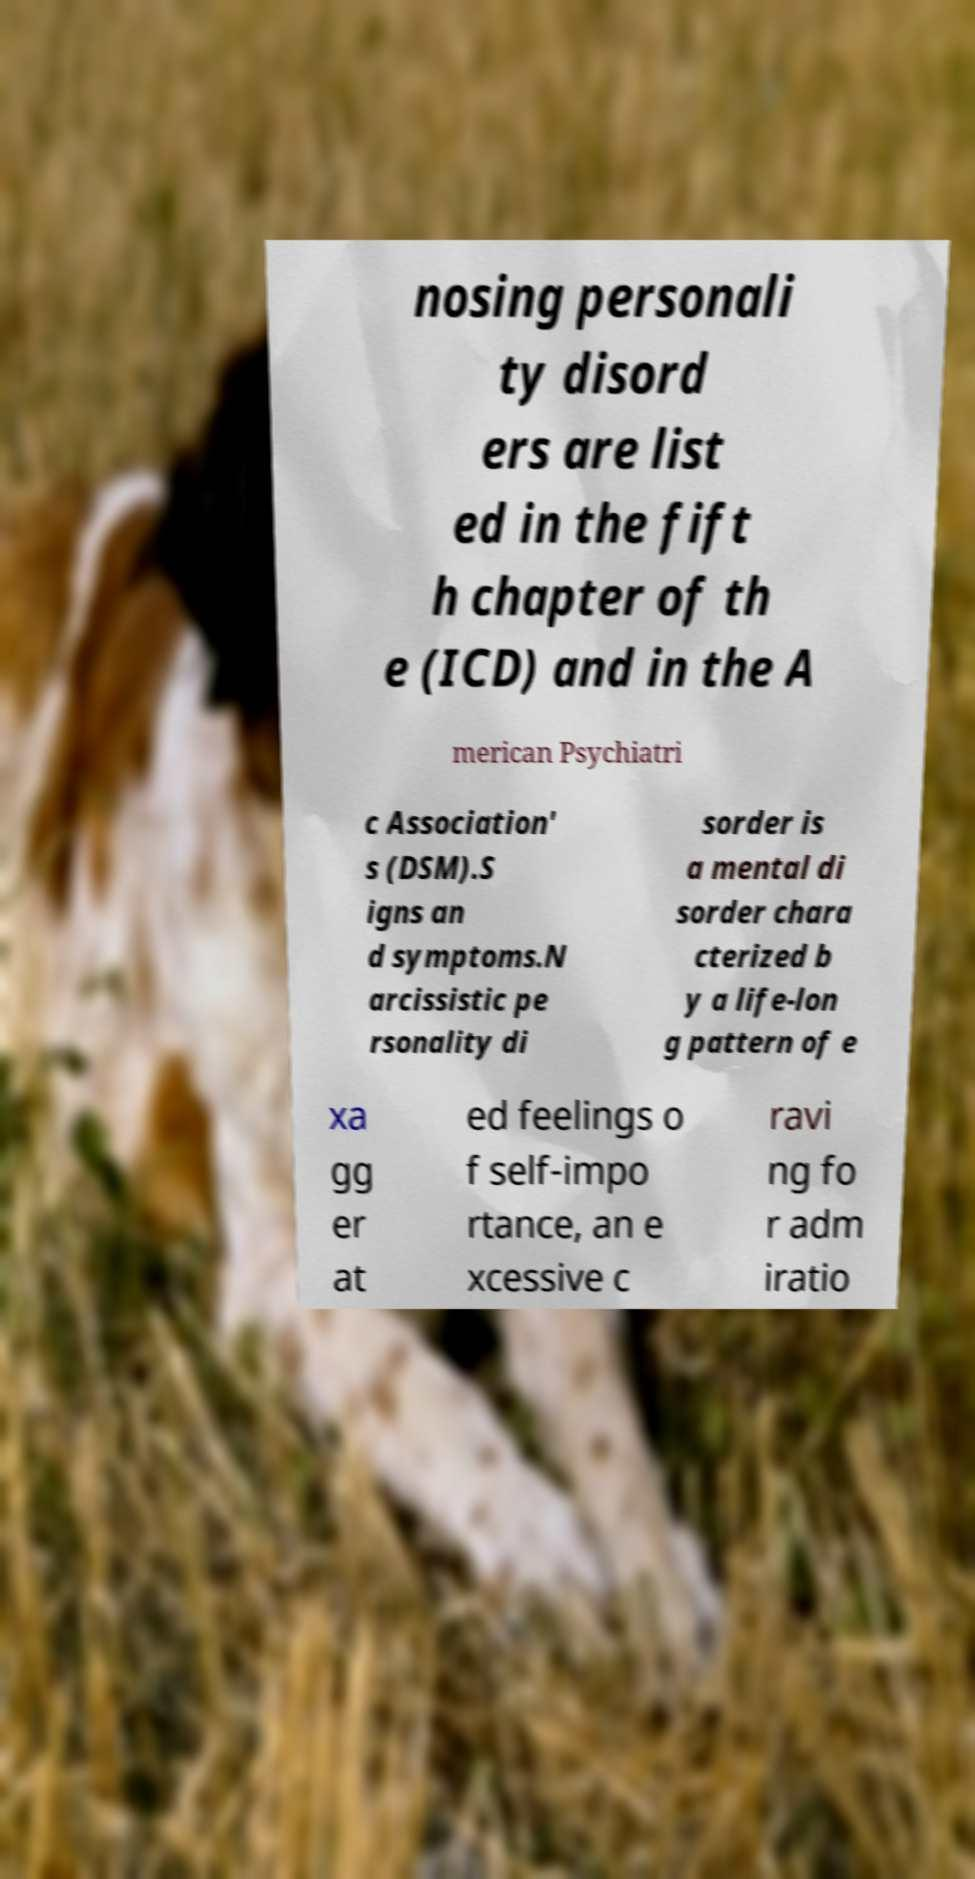Could you assist in decoding the text presented in this image and type it out clearly? nosing personali ty disord ers are list ed in the fift h chapter of th e (ICD) and in the A merican Psychiatri c Association' s (DSM).S igns an d symptoms.N arcissistic pe rsonality di sorder is a mental di sorder chara cterized b y a life-lon g pattern of e xa gg er at ed feelings o f self-impo rtance, an e xcessive c ravi ng fo r adm iratio 